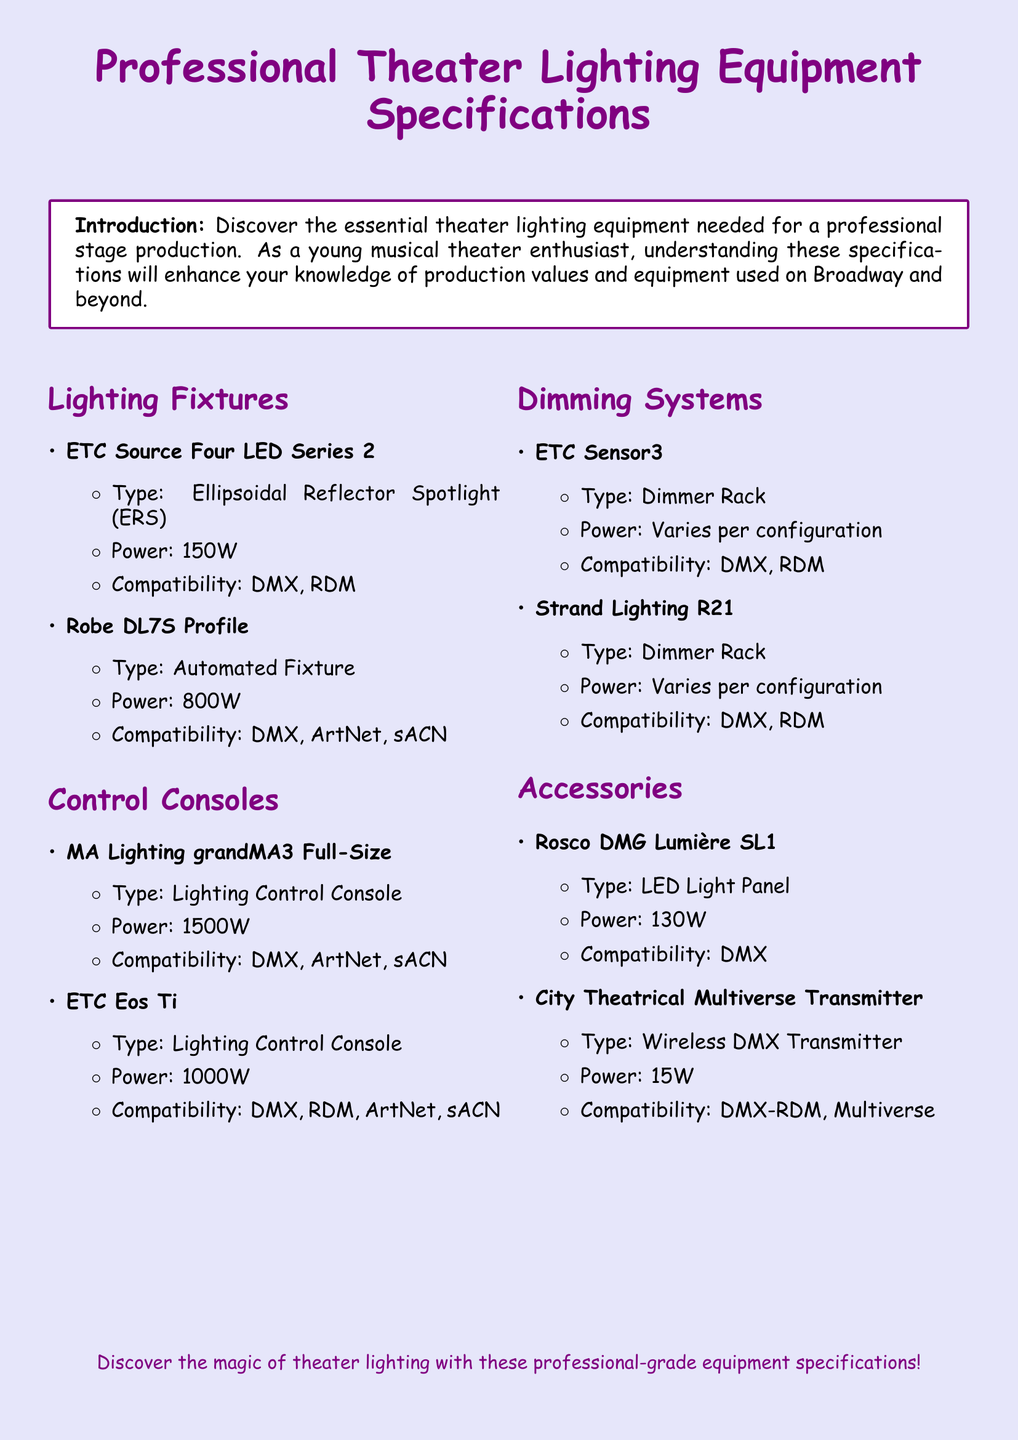What is the power consumption of the ETC Source Four LED Series 2? The power consumption is listed in the specifications under "Power" for the ETC Source Four LED Series 2, which is 150W.
Answer: 150W What type of lighting fixture is the Robe DL7S Profile? The document specifies the type of the Robe DL7S Profile under "Type," which is an Automated Fixture.
Answer: Automated Fixture How much power does the MA Lighting grandMA3 Full-Size consume? The power consumption for the MA Lighting grandMA3 Full-Size is provided under "Power," which is 1500W.
Answer: 1500W Which control console has compatibility with RDM? The document mentions compatibility for control consoles, specifically the ETC Eos Ti, which includes DMX, RDM, ArtNet, and sACN.
Answer: ETC Eos Ti What is the type of the City Theatrical Multiverse Transmitter? The document specifies the type of the City Theatrical Multiverse Transmitter as a Wireless DMX Transmitter under "Type."
Answer: Wireless DMX Transmitter What are the types of dimmer racks listed in the document? The document lists two types of dimmer racks under "Dimming Systems," which are ETC Sensor3 and Strand Lighting R21.
Answer: ETC Sensor3 and Strand Lighting R21 How many watts does the Rosco DMG Lumière SL1 consume? The power consumption for the Rosco DMG Lumière SL1 is provided, which is 130W.
Answer: 130W What compatibility does the ETC Sensor3 have? The compatibility for the ETC Sensor3 is listed under "Compatibility," which includes DMX and RDM.
Answer: DMX, RDM How many types of lighting control consoles are mentioned? The document details two types of lighting control consoles under "Control Consoles," which are MA Lighting grandMA3 Full-Size and ETC Eos Ti.
Answer: Two 